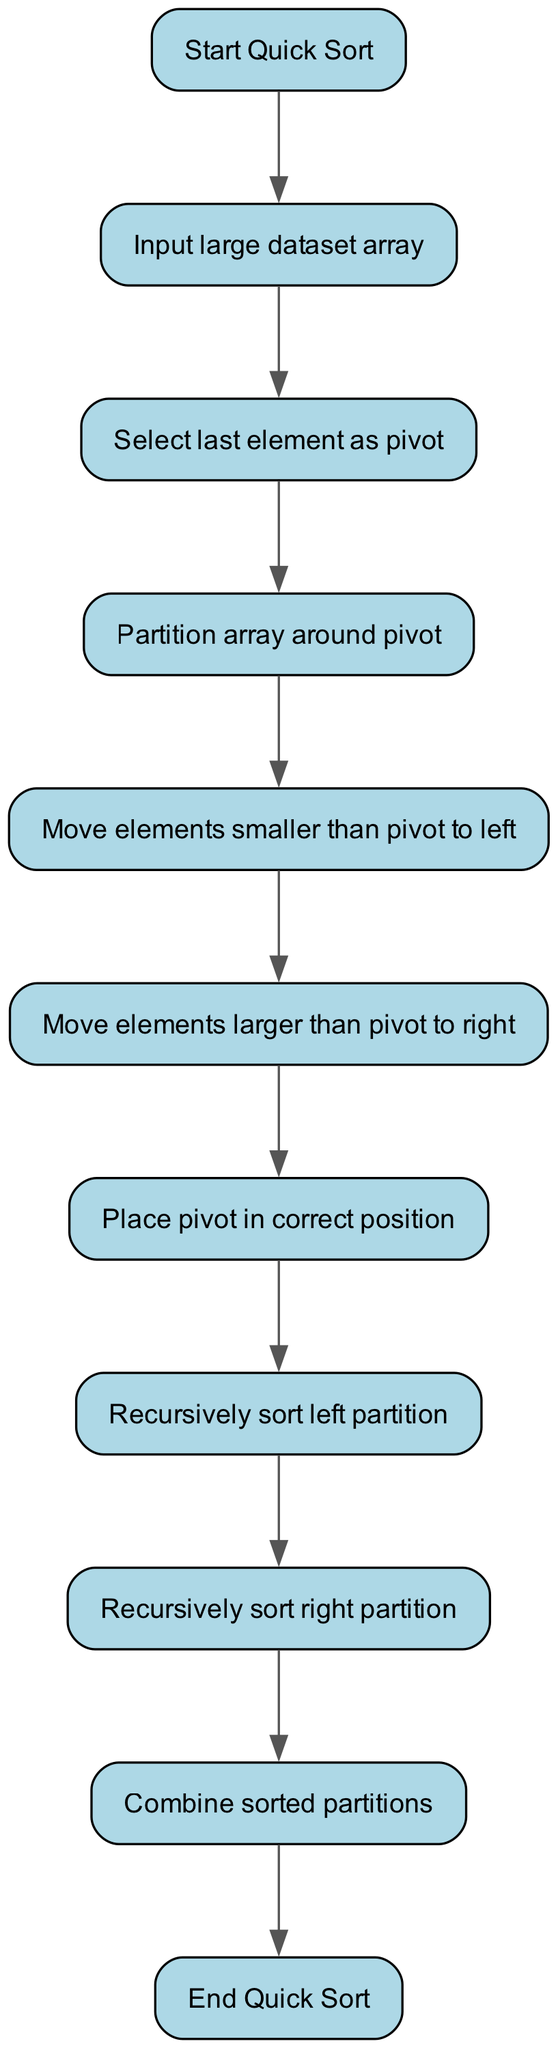What is the first node in the diagram? The diagram starts with the "Start Quick Sort" node, which is the first element in the flow.
Answer: Start Quick Sort How many nodes are there in total? There are ten nodes present in the diagram, each representing a different step in the quick sort process.
Answer: Ten What is the last step of the quick sort process in the diagram? The last step represented in the diagram is "End Quick Sort," which concludes the sorting process.
Answer: End Quick Sort What is the relationship between the "Partition array around pivot" and "Move elements smaller than pivot to left"? The "Partition array around pivot" node leads directly to the "Move elements smaller than pivot to left" node, indicating a sequential processing step.
Answer: They're sequential Which node comes after "Place pivot in correct position"? After the "Place pivot in correct position" node, the next step is "Recursively sort left partition."
Answer: Recursively sort left partition What do the arrows in the flowchart represent? The arrows indicate the direction of the flow of steps and the sequence in which the quick sort algorithm processes the dataset.
Answer: Direction of flow What does the node "Recursively sort right partition" indicate in terms of the process? This node represents a recursive step, showing that the algorithm will apply the same sorting logic to the right partition after sorting the left partition.
Answer: A recursive step Which node follows "Move elements larger than pivot to right"? The node that follows "Move elements larger than pivot to right" is "Place pivot in correct position."
Answer: Place pivot in correct position How many partitioning steps are shown in the diagram? There are two partitioning steps indicated: moving elements smaller and larger than the pivot.
Answer: Two 